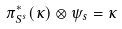<formula> <loc_0><loc_0><loc_500><loc_500>\pi _ { S ^ { s } } ^ { * } ( \kappa ) \otimes \psi _ { s } = \kappa</formula> 